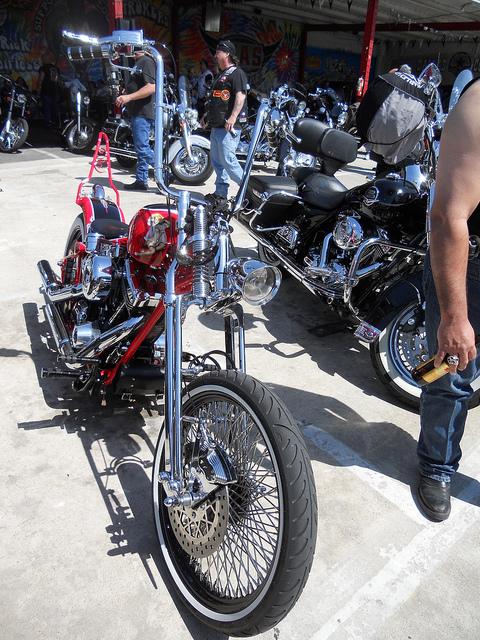What color is this motorcycle?
Quick response, please. Red. Is the man in front wearing a ring?
Answer briefly. Yes. Are the men going on a race?
Give a very brief answer. No. 